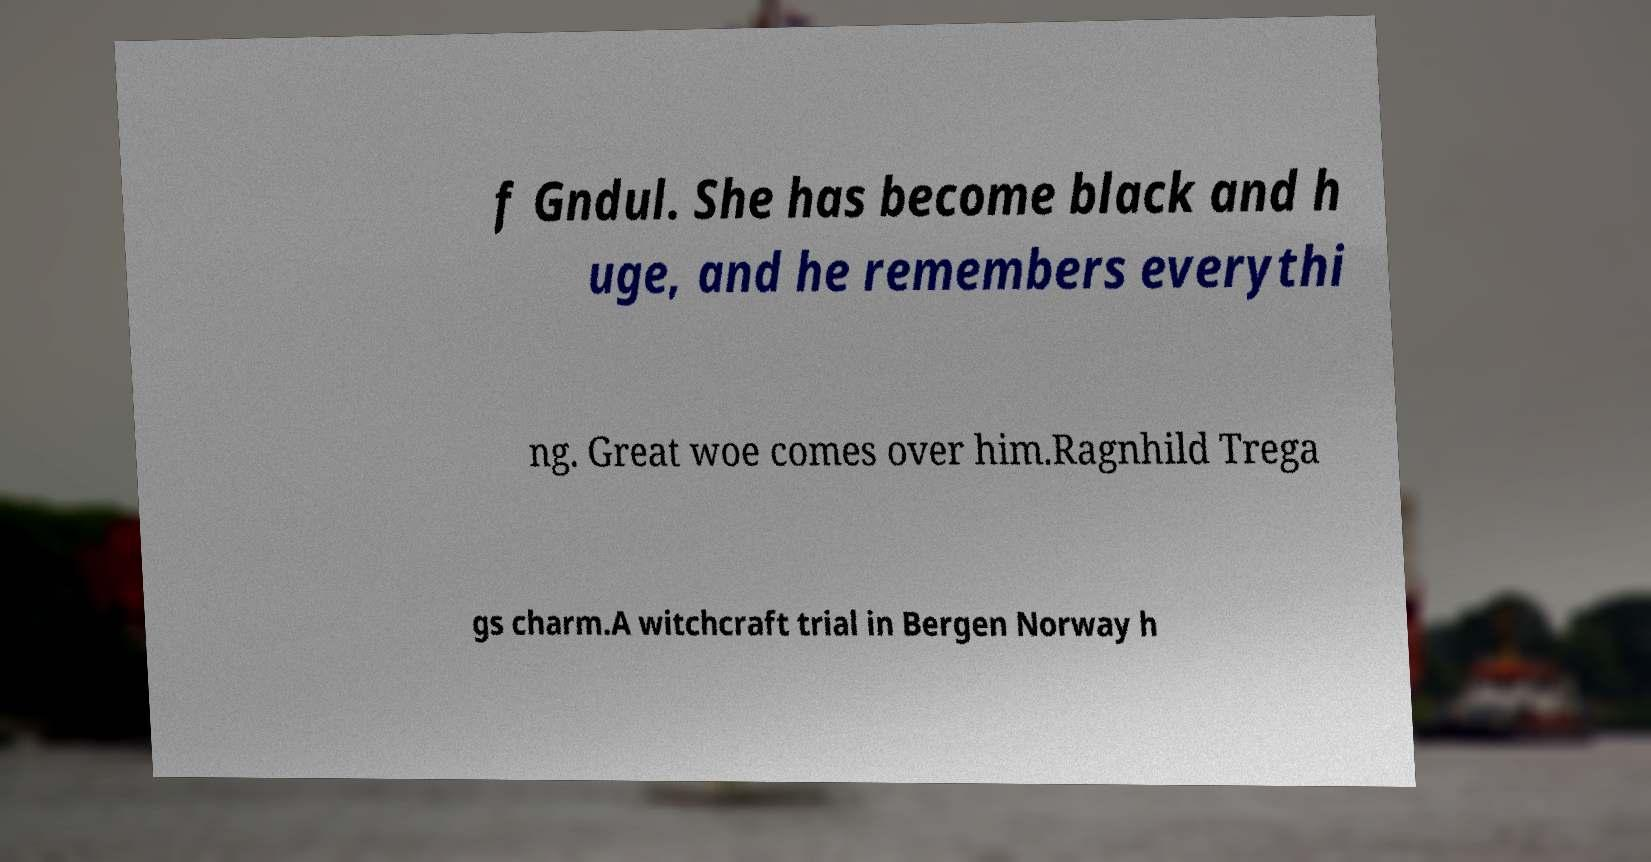For documentation purposes, I need the text within this image transcribed. Could you provide that? f Gndul. She has become black and h uge, and he remembers everythi ng. Great woe comes over him.Ragnhild Trega gs charm.A witchcraft trial in Bergen Norway h 